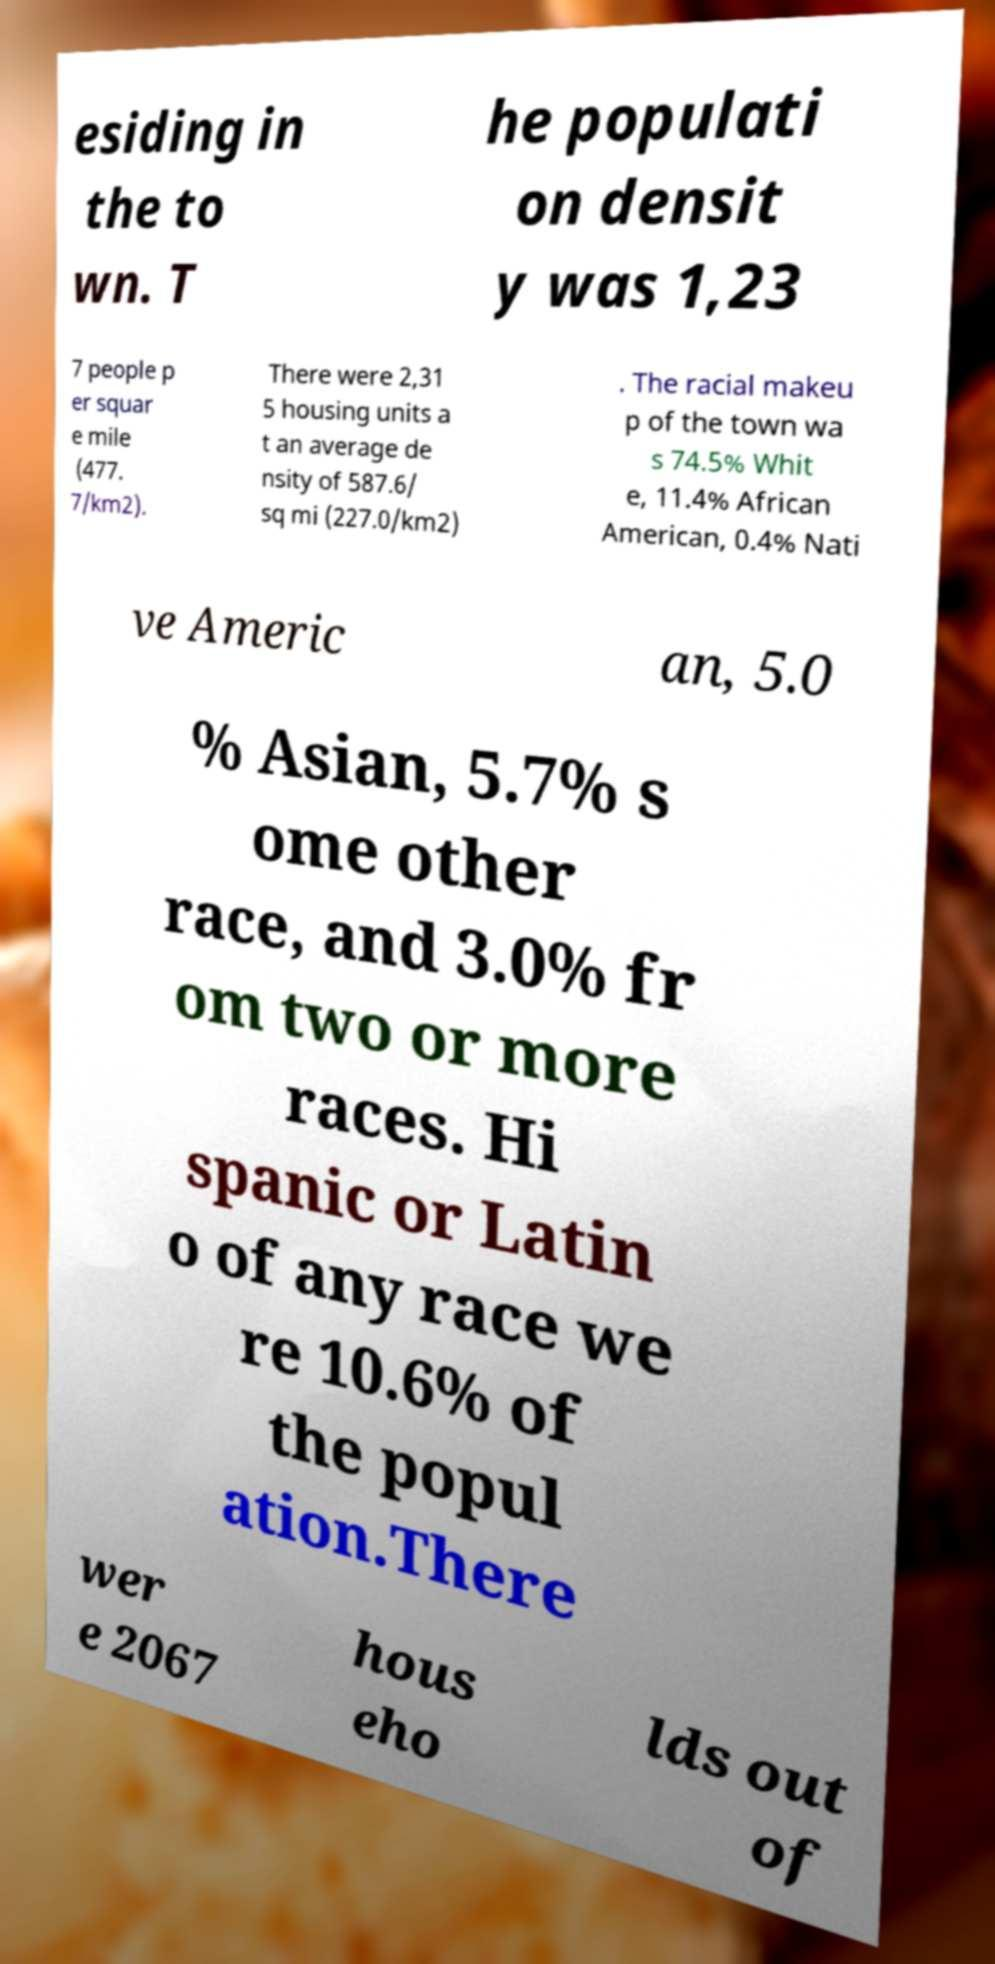Could you extract and type out the text from this image? esiding in the to wn. T he populati on densit y was 1,23 7 people p er squar e mile (477. 7/km2). There were 2,31 5 housing units a t an average de nsity of 587.6/ sq mi (227.0/km2) . The racial makeu p of the town wa s 74.5% Whit e, 11.4% African American, 0.4% Nati ve Americ an, 5.0 % Asian, 5.7% s ome other race, and 3.0% fr om two or more races. Hi spanic or Latin o of any race we re 10.6% of the popul ation.There wer e 2067 hous eho lds out of 